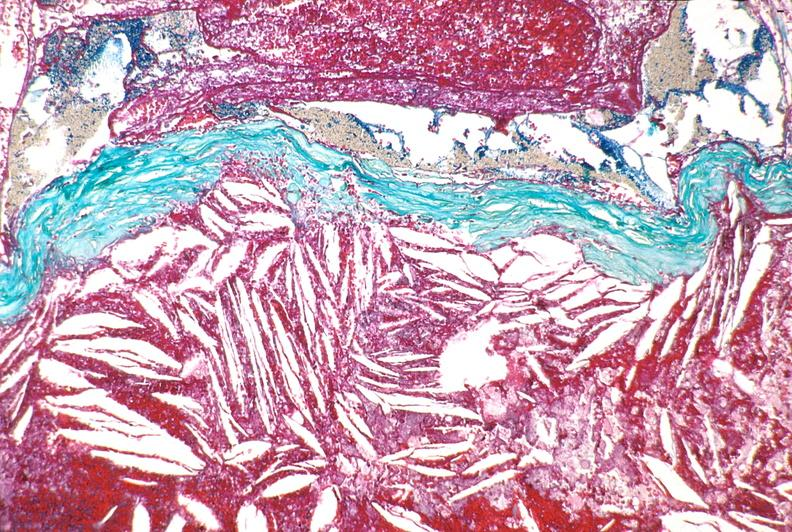s nipple duplication present?
Answer the question using a single word or phrase. No 